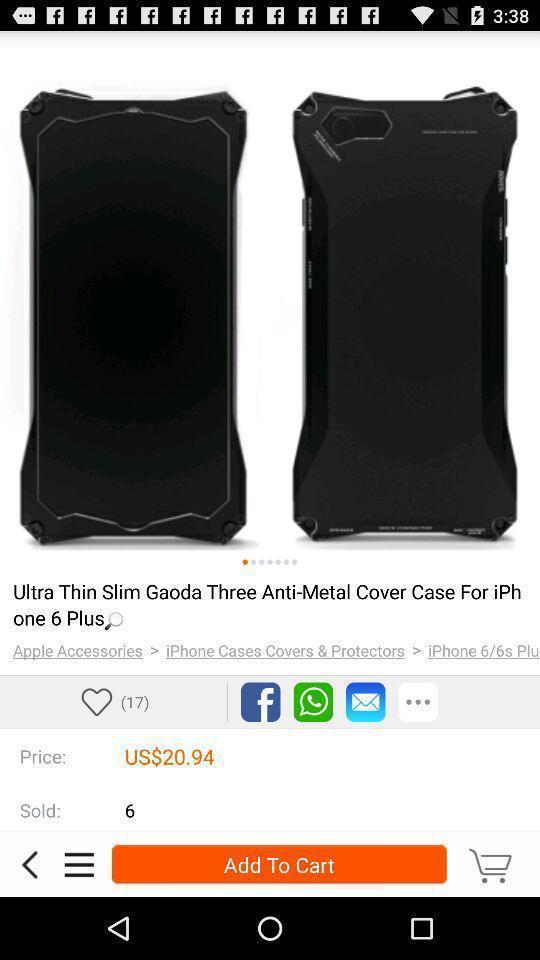Provide a description of this screenshot. Screen showing page of an shopping application. 